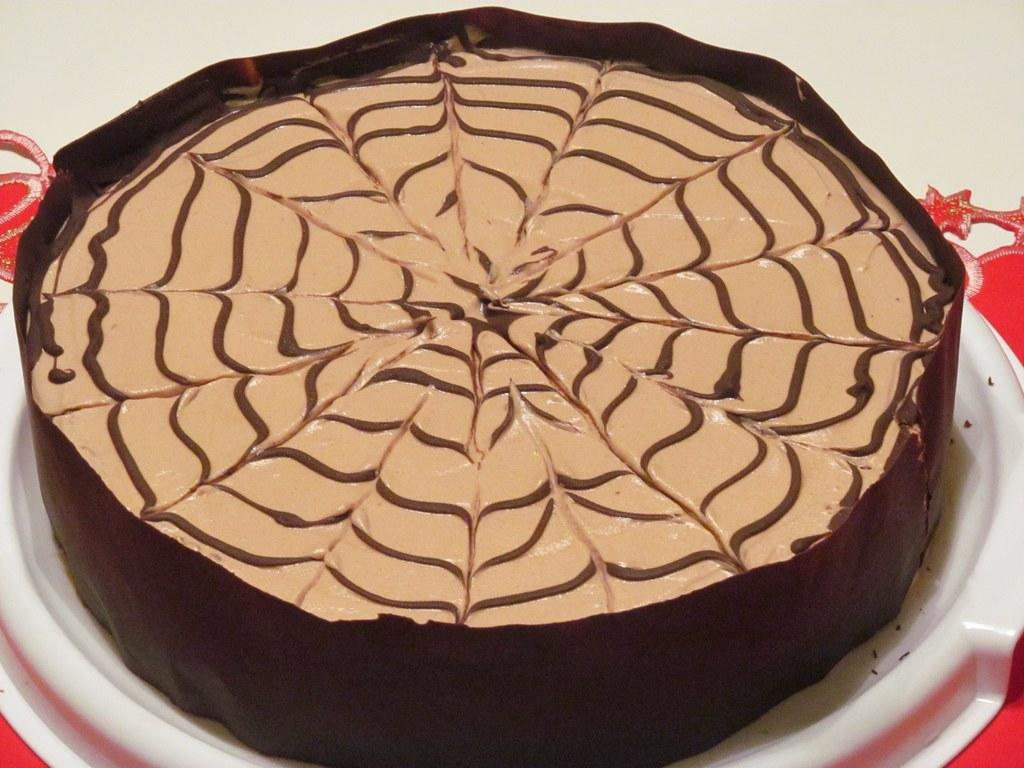What is the main subject of the image? The main subject of the image is a cake. How is the cake presented in the image? The cake is served on a plate in the image. What book is the person reading in the square in the image? There is no person, book, or square present in the image; it only features a cake served on a plate. 